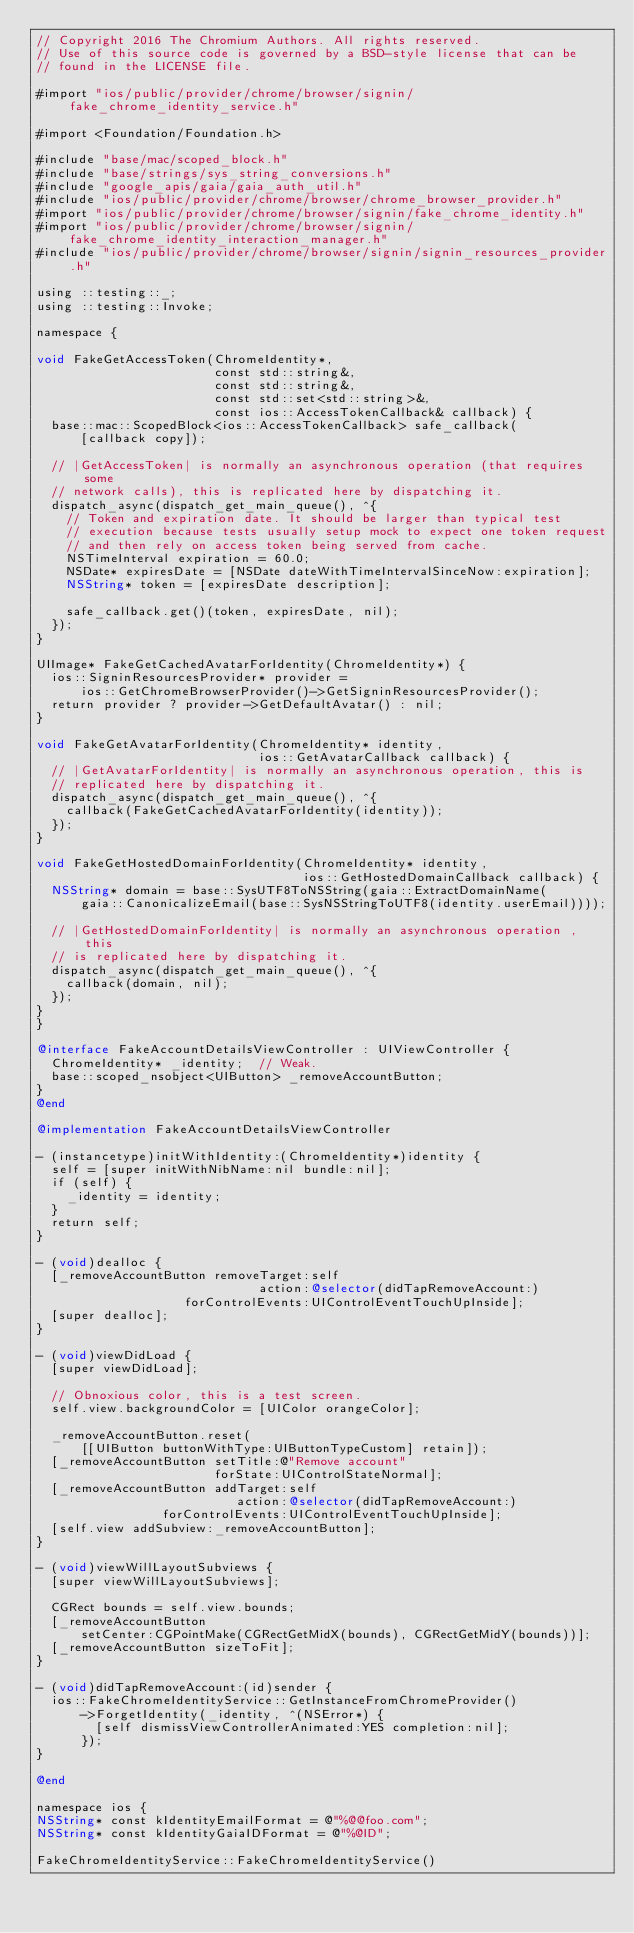<code> <loc_0><loc_0><loc_500><loc_500><_ObjectiveC_>// Copyright 2016 The Chromium Authors. All rights reserved.
// Use of this source code is governed by a BSD-style license that can be
// found in the LICENSE file.

#import "ios/public/provider/chrome/browser/signin/fake_chrome_identity_service.h"

#import <Foundation/Foundation.h>

#include "base/mac/scoped_block.h"
#include "base/strings/sys_string_conversions.h"
#include "google_apis/gaia/gaia_auth_util.h"
#include "ios/public/provider/chrome/browser/chrome_browser_provider.h"
#import "ios/public/provider/chrome/browser/signin/fake_chrome_identity.h"
#import "ios/public/provider/chrome/browser/signin/fake_chrome_identity_interaction_manager.h"
#include "ios/public/provider/chrome/browser/signin/signin_resources_provider.h"

using ::testing::_;
using ::testing::Invoke;

namespace {

void FakeGetAccessToken(ChromeIdentity*,
                        const std::string&,
                        const std::string&,
                        const std::set<std::string>&,
                        const ios::AccessTokenCallback& callback) {
  base::mac::ScopedBlock<ios::AccessTokenCallback> safe_callback(
      [callback copy]);

  // |GetAccessToken| is normally an asynchronous operation (that requires some
  // network calls), this is replicated here by dispatching it.
  dispatch_async(dispatch_get_main_queue(), ^{
    // Token and expiration date. It should be larger than typical test
    // execution because tests usually setup mock to expect one token request
    // and then rely on access token being served from cache.
    NSTimeInterval expiration = 60.0;
    NSDate* expiresDate = [NSDate dateWithTimeIntervalSinceNow:expiration];
    NSString* token = [expiresDate description];

    safe_callback.get()(token, expiresDate, nil);
  });
}

UIImage* FakeGetCachedAvatarForIdentity(ChromeIdentity*) {
  ios::SigninResourcesProvider* provider =
      ios::GetChromeBrowserProvider()->GetSigninResourcesProvider();
  return provider ? provider->GetDefaultAvatar() : nil;
}

void FakeGetAvatarForIdentity(ChromeIdentity* identity,
                              ios::GetAvatarCallback callback) {
  // |GetAvatarForIdentity| is normally an asynchronous operation, this is
  // replicated here by dispatching it.
  dispatch_async(dispatch_get_main_queue(), ^{
    callback(FakeGetCachedAvatarForIdentity(identity));
  });
}

void FakeGetHostedDomainForIdentity(ChromeIdentity* identity,
                                    ios::GetHostedDomainCallback callback) {
  NSString* domain = base::SysUTF8ToNSString(gaia::ExtractDomainName(
      gaia::CanonicalizeEmail(base::SysNSStringToUTF8(identity.userEmail))));

  // |GetHostedDomainForIdentity| is normally an asynchronous operation , this
  // is replicated here by dispatching it.
  dispatch_async(dispatch_get_main_queue(), ^{
    callback(domain, nil);
  });
}
}

@interface FakeAccountDetailsViewController : UIViewController {
  ChromeIdentity* _identity;  // Weak.
  base::scoped_nsobject<UIButton> _removeAccountButton;
}
@end

@implementation FakeAccountDetailsViewController

- (instancetype)initWithIdentity:(ChromeIdentity*)identity {
  self = [super initWithNibName:nil bundle:nil];
  if (self) {
    _identity = identity;
  }
  return self;
}

- (void)dealloc {
  [_removeAccountButton removeTarget:self
                              action:@selector(didTapRemoveAccount:)
                    forControlEvents:UIControlEventTouchUpInside];
  [super dealloc];
}

- (void)viewDidLoad {
  [super viewDidLoad];

  // Obnoxious color, this is a test screen.
  self.view.backgroundColor = [UIColor orangeColor];

  _removeAccountButton.reset(
      [[UIButton buttonWithType:UIButtonTypeCustom] retain]);
  [_removeAccountButton setTitle:@"Remove account"
                        forState:UIControlStateNormal];
  [_removeAccountButton addTarget:self
                           action:@selector(didTapRemoveAccount:)
                 forControlEvents:UIControlEventTouchUpInside];
  [self.view addSubview:_removeAccountButton];
}

- (void)viewWillLayoutSubviews {
  [super viewWillLayoutSubviews];

  CGRect bounds = self.view.bounds;
  [_removeAccountButton
      setCenter:CGPointMake(CGRectGetMidX(bounds), CGRectGetMidY(bounds))];
  [_removeAccountButton sizeToFit];
}

- (void)didTapRemoveAccount:(id)sender {
  ios::FakeChromeIdentityService::GetInstanceFromChromeProvider()
      ->ForgetIdentity(_identity, ^(NSError*) {
        [self dismissViewControllerAnimated:YES completion:nil];
      });
}

@end

namespace ios {
NSString* const kIdentityEmailFormat = @"%@@foo.com";
NSString* const kIdentityGaiaIDFormat = @"%@ID";

FakeChromeIdentityService::FakeChromeIdentityService()</code> 